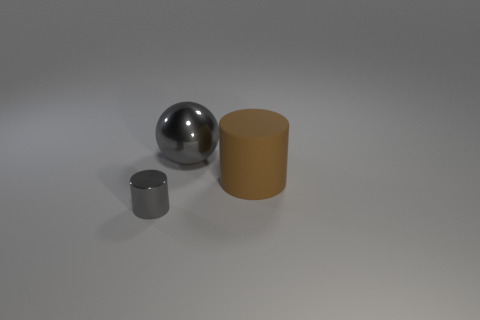Add 2 large rubber cylinders. How many objects exist? 5 Subtract all cylinders. How many objects are left? 1 Subtract all gray cylinders. How many cylinders are left? 1 Subtract all red cylinders. Subtract all yellow spheres. How many cylinders are left? 2 Add 1 large gray shiny balls. How many large gray shiny balls exist? 2 Subtract 1 gray cylinders. How many objects are left? 2 Subtract all gray shiny cubes. Subtract all large balls. How many objects are left? 2 Add 1 big gray shiny spheres. How many big gray shiny spheres are left? 2 